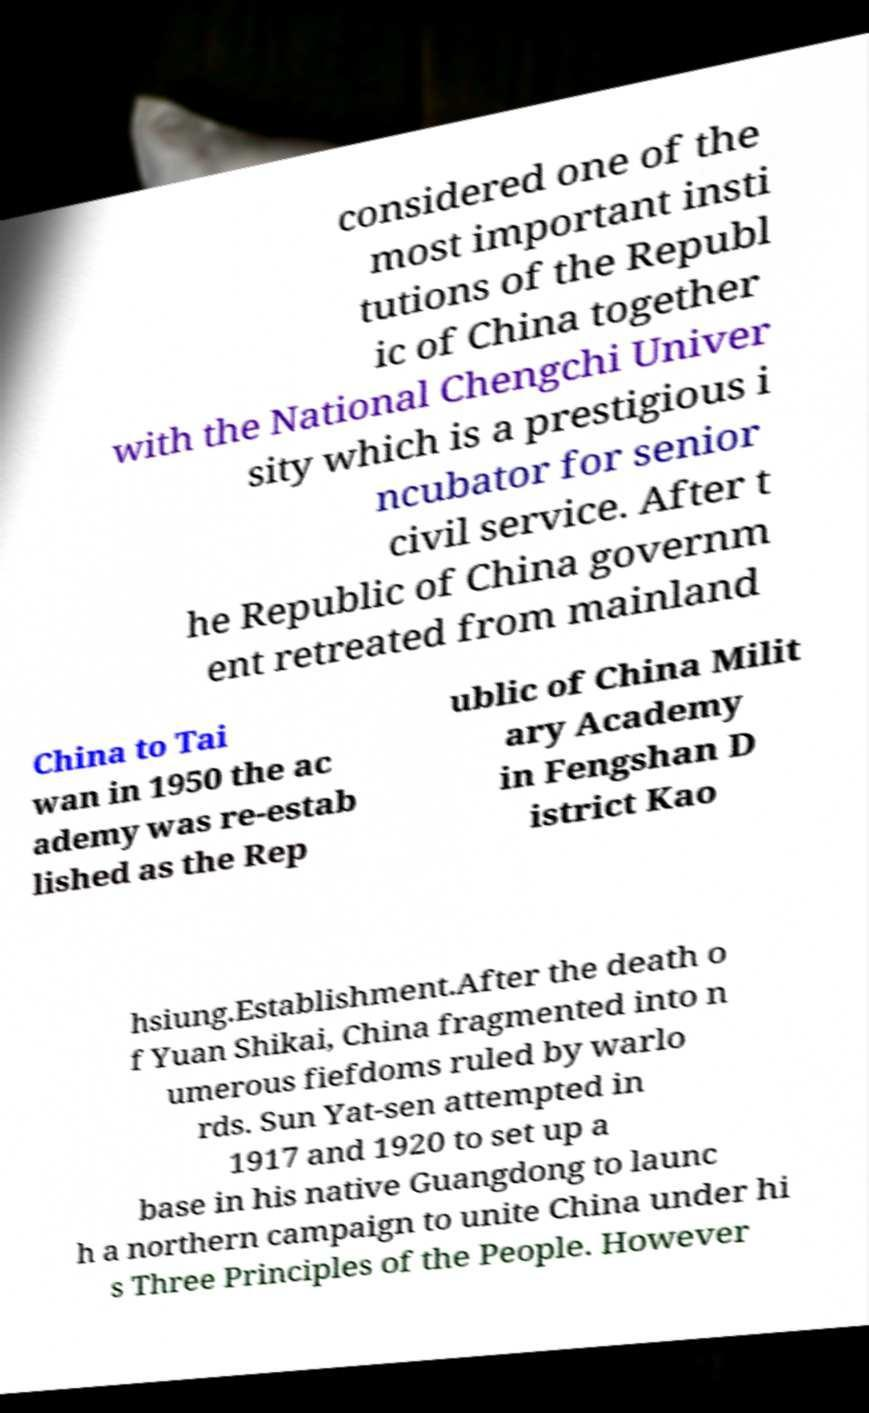Can you read and provide the text displayed in the image?This photo seems to have some interesting text. Can you extract and type it out for me? considered one of the most important insti tutions of the Republ ic of China together with the National Chengchi Univer sity which is a prestigious i ncubator for senior civil service. After t he Republic of China governm ent retreated from mainland China to Tai wan in 1950 the ac ademy was re-estab lished as the Rep ublic of China Milit ary Academy in Fengshan D istrict Kao hsiung.Establishment.After the death o f Yuan Shikai, China fragmented into n umerous fiefdoms ruled by warlo rds. Sun Yat-sen attempted in 1917 and 1920 to set up a base in his native Guangdong to launc h a northern campaign to unite China under hi s Three Principles of the People. However 